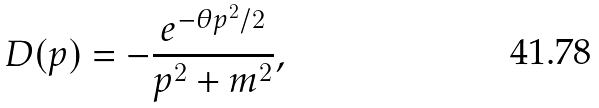<formula> <loc_0><loc_0><loc_500><loc_500>D ( p ) = - \frac { e ^ { - \theta p ^ { 2 } / 2 } } { p ^ { 2 } + m ^ { 2 } } ,</formula> 